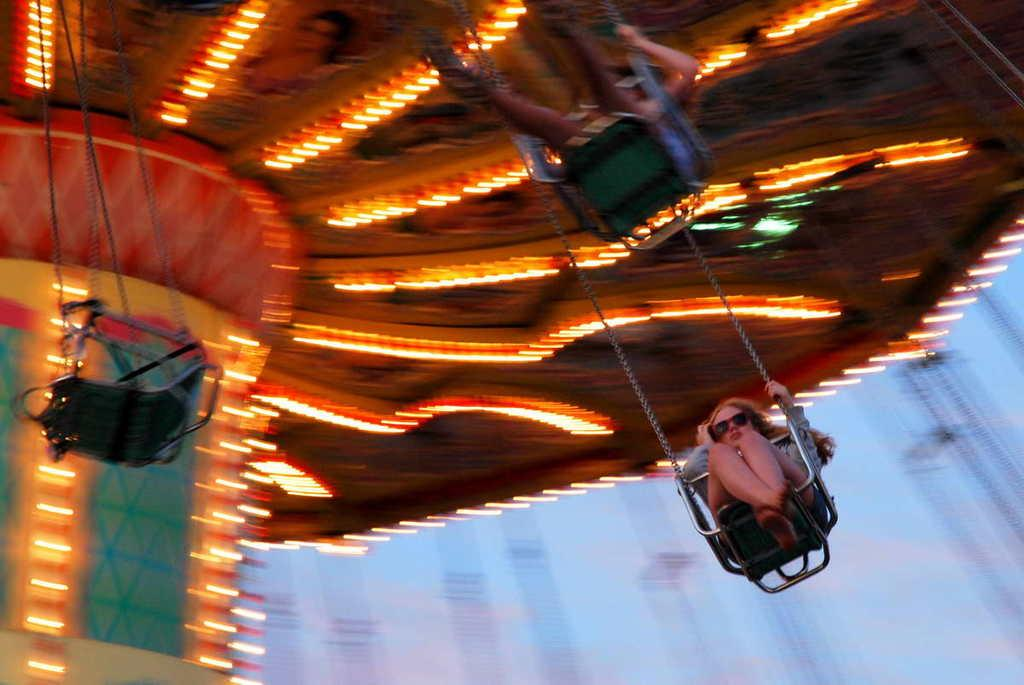How many people are in the image? There are two people in the image. What are the people doing in the image? The people are sitting on swings. What type of ride are the swings part of? The swings are part of a flying swing ride. What can be seen in the background of the image? There are lights visible in the image. What type of patch is being sewn onto the bears' clothing in the image? There are no bears or patches present in the image; it features two people sitting on swings. What type of beef is being served at the restaurant in the image? There is no restaurant or beef present in the image; it features two people sitting on swings. 